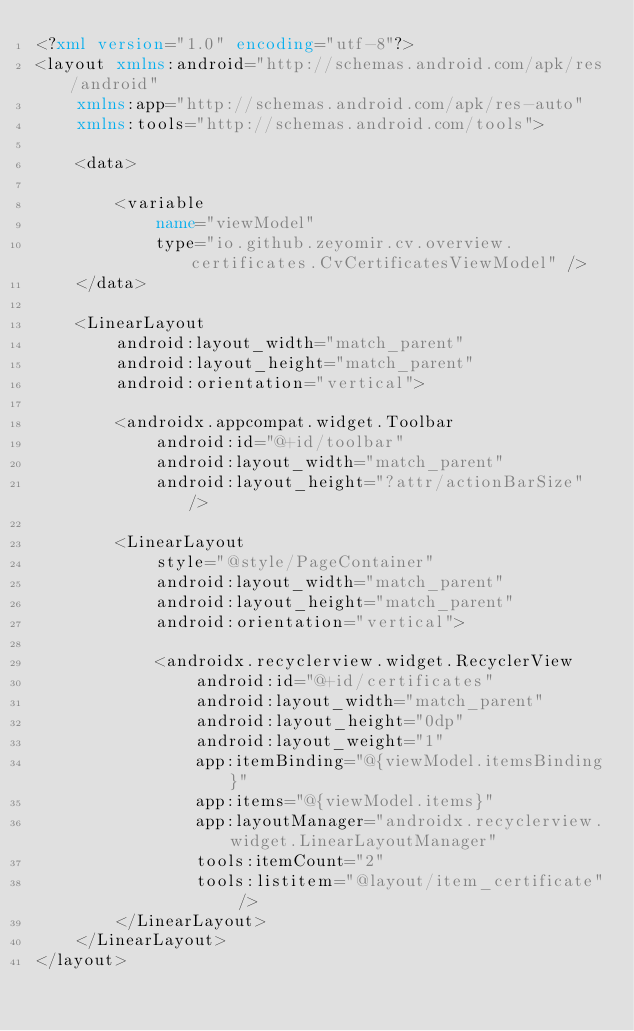<code> <loc_0><loc_0><loc_500><loc_500><_XML_><?xml version="1.0" encoding="utf-8"?>
<layout xmlns:android="http://schemas.android.com/apk/res/android"
    xmlns:app="http://schemas.android.com/apk/res-auto"
    xmlns:tools="http://schemas.android.com/tools">

    <data>

        <variable
            name="viewModel"
            type="io.github.zeyomir.cv.overview.certificates.CvCertificatesViewModel" />
    </data>

    <LinearLayout
        android:layout_width="match_parent"
        android:layout_height="match_parent"
        android:orientation="vertical">

        <androidx.appcompat.widget.Toolbar
            android:id="@+id/toolbar"
            android:layout_width="match_parent"
            android:layout_height="?attr/actionBarSize" />

        <LinearLayout
            style="@style/PageContainer"
            android:layout_width="match_parent"
            android:layout_height="match_parent"
            android:orientation="vertical">

            <androidx.recyclerview.widget.RecyclerView
                android:id="@+id/certificates"
                android:layout_width="match_parent"
                android:layout_height="0dp"
                android:layout_weight="1"
                app:itemBinding="@{viewModel.itemsBinding}"
                app:items="@{viewModel.items}"
                app:layoutManager="androidx.recyclerview.widget.LinearLayoutManager"
                tools:itemCount="2"
                tools:listitem="@layout/item_certificate" />
        </LinearLayout>
    </LinearLayout>
</layout>
</code> 